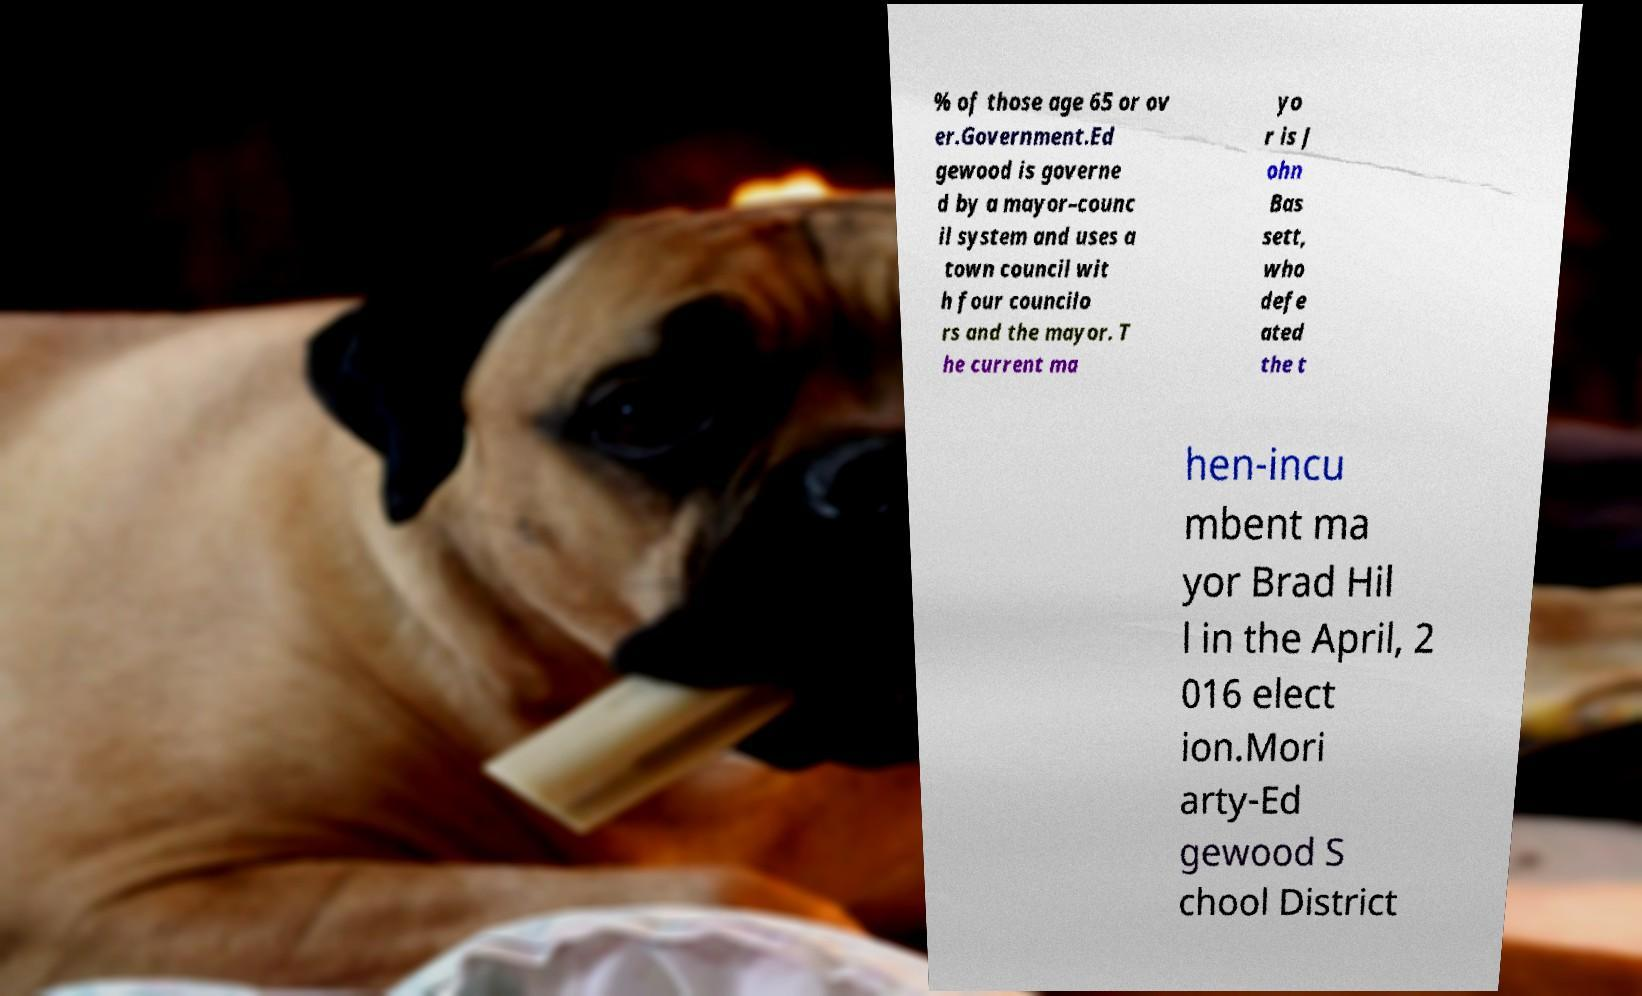Could you extract and type out the text from this image? % of those age 65 or ov er.Government.Ed gewood is governe d by a mayor–counc il system and uses a town council wit h four councilo rs and the mayor. T he current ma yo r is J ohn Bas sett, who defe ated the t hen-incu mbent ma yor Brad Hil l in the April, 2 016 elect ion.Mori arty-Ed gewood S chool District 